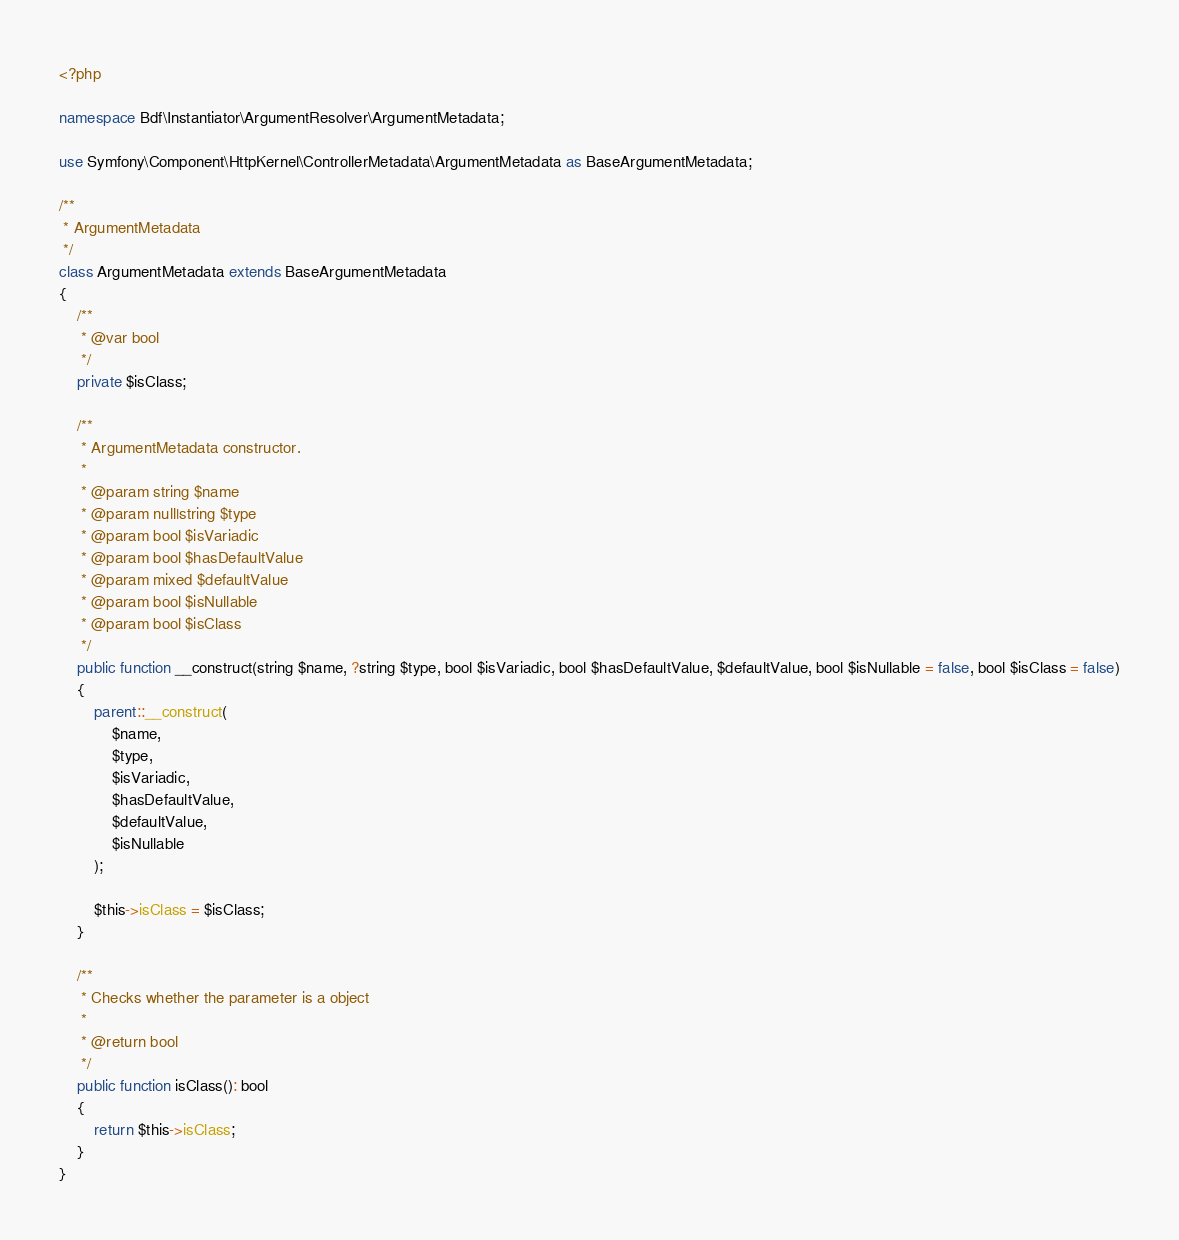<code> <loc_0><loc_0><loc_500><loc_500><_PHP_><?php

namespace Bdf\Instantiator\ArgumentResolver\ArgumentMetadata;

use Symfony\Component\HttpKernel\ControllerMetadata\ArgumentMetadata as BaseArgumentMetadata;

/**
 * ArgumentMetadata
 */
class ArgumentMetadata extends BaseArgumentMetadata
{
    /**
     * @var bool
     */
    private $isClass;

    /**
     * ArgumentMetadata constructor.
     *
     * @param string $name
     * @param null|string $type
     * @param bool $isVariadic
     * @param bool $hasDefaultValue
     * @param mixed $defaultValue
     * @param bool $isNullable
     * @param bool $isClass
     */
    public function __construct(string $name, ?string $type, bool $isVariadic, bool $hasDefaultValue, $defaultValue, bool $isNullable = false, bool $isClass = false)
    {
        parent::__construct(
            $name,
            $type,
            $isVariadic,
            $hasDefaultValue,
            $defaultValue,
            $isNullable
        );

        $this->isClass = $isClass;
    }

    /**
     * Checks whether the parameter is a object
     *
     * @return bool
     */
    public function isClass(): bool
    {
        return $this->isClass;
    }
}
</code> 